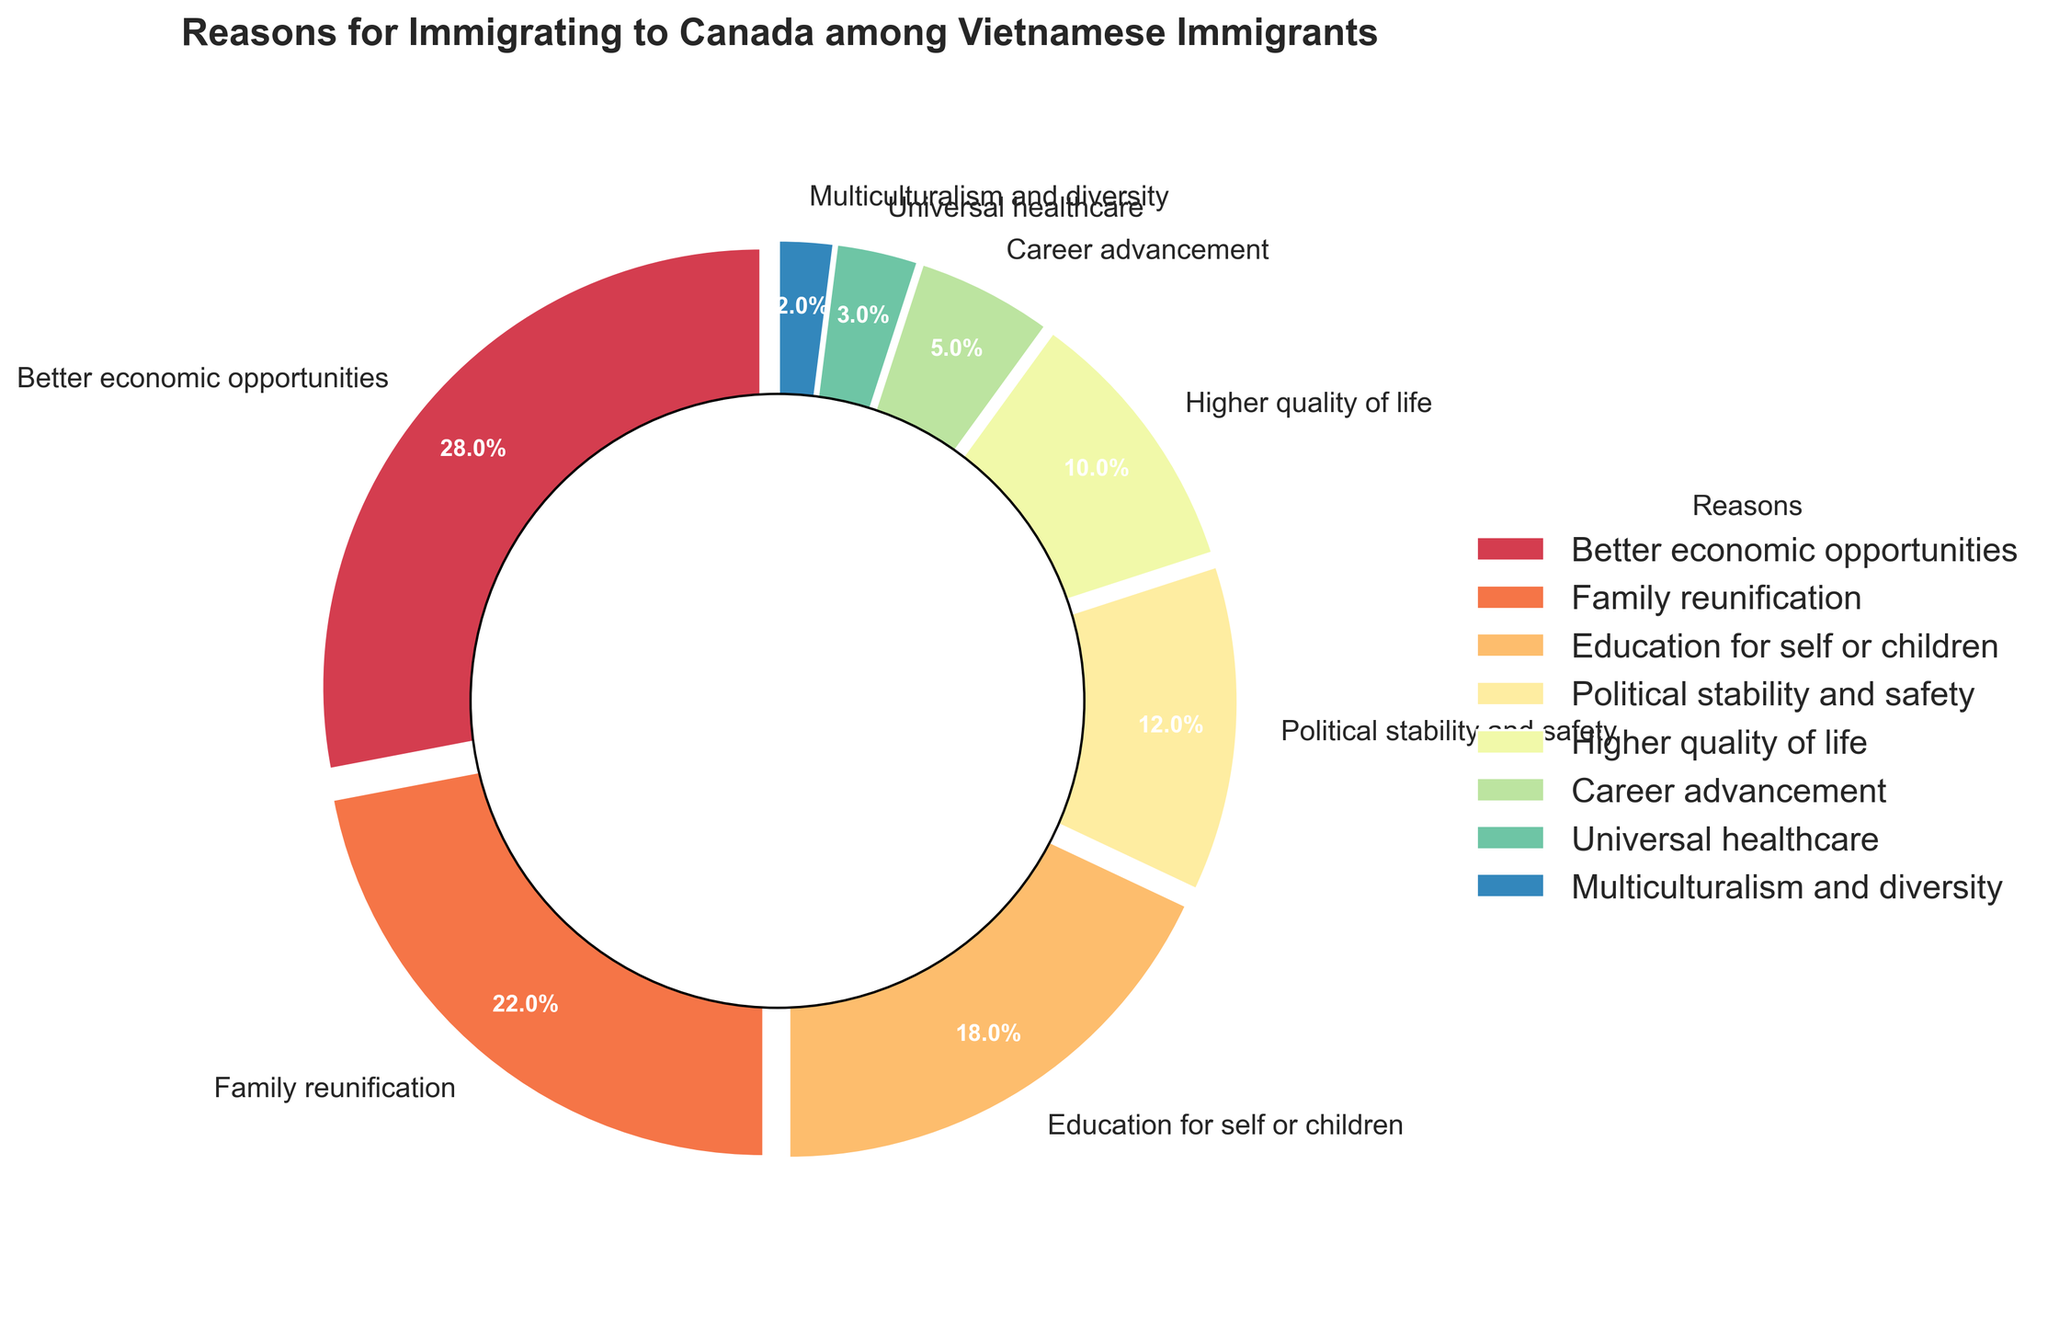What is the most common reason for immigrating to Canada among Vietnamese immigrants? The figure shows the percentage of each reason for immigrating to Canada. The segment with the highest percentage represents the most common reason. "Better economic opportunities" has the highest percentage of 28%.
Answer: Better economic opportunities Which two reasons have the closest percentages? By comparing the percentages, "Education for self or children" (18%) and "Political stability and safety" (12%) have relatively close percentages, but "Family reunification" (22%) and "Education for self or children" (18%) are closer. The difference between them is 22% - 18% = 4%.
Answer: Family reunification and Education for self or children What is the total percentage of reasons related to personal or family improvements (Better economic opportunities, Education for self or children, Higher quality of life, Career advancement)? Summing up the related percentages: 28% (Better economic opportunities) + 18% (Education for self or children) + 10% (Higher quality of life) + 5% (Career advancement) = 61%
Answer: 61% How much greater is the percentage for "Better economic opportunities" compared to "Multiculturalism and diversity"? Subtract the percentage of "Multiculturalism and diversity" from "Better economic opportunities": 28% - 2% = 26%
Answer: 26% Which reason has the least percentage representation? The segment with the smallest percentage represents the least common reason. "Multiculturalism and diversity" has the smallest percentage at 2%.
Answer: Multiculturalism and diversity Are there more Vietnamese immigrants citing "Family reunification" or "Political stability and safety"? By comparing the percentages for "Family reunification" (22%) and "Political stability and safety" (12%), "Family reunification" is higher.
Answer: Family reunification What is the combined percentage of "Universal healthcare" and "Multiculturalism and diversity"? Adding the percentages for "Universal healthcare" (3%) and "Multiculturalism and diversity" (2%): 3% + 2% = 5%
Answer: 5% What percentage of reasons are classified as less than 10%? The reasons classified as less than 10% are "Higher quality of life" (10%), "Career advancement" (5%), "Universal healthcare" (3%), and "Multiculturalism and diversity" (2%). Summing these, 10% + 5% + 3% + 2% = 20%
Answer: 20% Among the reasons given, what can be described as fundamentally economic reasons? (Better economic opportunities, Career advancement) Adding the percentages for "Better economic opportunities" (28%) and "Career advancement" (5%): 28% + 5% = 33%
Answer: 33% Which reason has twice the percentage of "Universal healthcare"? To find the reason with about twice the percentage of "Universal healthcare" (3%), we need to identify the closest value to 3% * 2 = 6%. "Career advancement" has a percentage of 5%, which is closest but less than double.
Answer: None (closest is Career advancement at 5%) 